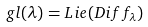<formula> <loc_0><loc_0><loc_500><loc_500>g l ( \lambda ) = L i e ( D i f f _ { \lambda } )</formula> 